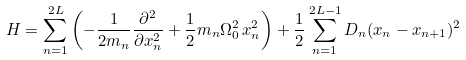Convert formula to latex. <formula><loc_0><loc_0><loc_500><loc_500>H = \sum _ { n = 1 } ^ { 2 L } \left ( - \frac { 1 } { 2 m _ { n } } \frac { \partial ^ { 2 } } { \partial x ^ { 2 } _ { n } } + \frac { 1 } { 2 } m _ { n } \Omega _ { 0 } ^ { 2 } \, x ^ { 2 } _ { n } \right ) + \frac { 1 } { 2 } \sum _ { n = 1 } ^ { 2 L - 1 } D _ { n } ( x _ { n } - x _ { n + 1 } ) ^ { 2 }</formula> 